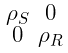<formula> <loc_0><loc_0><loc_500><loc_500>\begin{smallmatrix} \rho _ { S } & 0 \\ 0 & \rho _ { R } \\ \end{smallmatrix}</formula> 